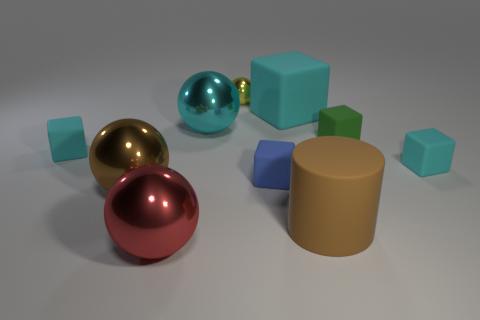How many cyan blocks must be subtracted to get 1 cyan blocks? 2 Subtract all big cyan rubber blocks. How many blocks are left? 4 Subtract all cylinders. How many objects are left? 9 Subtract all brown balls. How many balls are left? 3 Subtract 1 yellow balls. How many objects are left? 9 Subtract 1 cylinders. How many cylinders are left? 0 Subtract all gray cylinders. Subtract all gray balls. How many cylinders are left? 1 Subtract all green spheres. How many brown blocks are left? 0 Subtract all small brown cubes. Subtract all large brown objects. How many objects are left? 8 Add 2 tiny objects. How many tiny objects are left? 7 